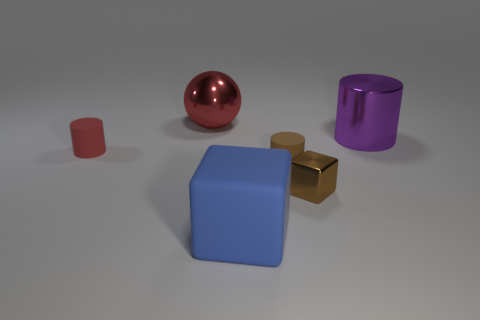Subtract all purple cylinders. How many cylinders are left? 2 Add 1 small yellow rubber blocks. How many objects exist? 7 Subtract 1 spheres. How many spheres are left? 0 Subtract all blue blocks. How many blocks are left? 1 Subtract all spheres. How many objects are left? 5 Subtract 0 gray spheres. How many objects are left? 6 Subtract all blue blocks. Subtract all gray cylinders. How many blocks are left? 1 Subtract all big things. Subtract all small things. How many objects are left? 0 Add 2 metallic spheres. How many metallic spheres are left? 3 Add 2 large green shiny cylinders. How many large green shiny cylinders exist? 2 